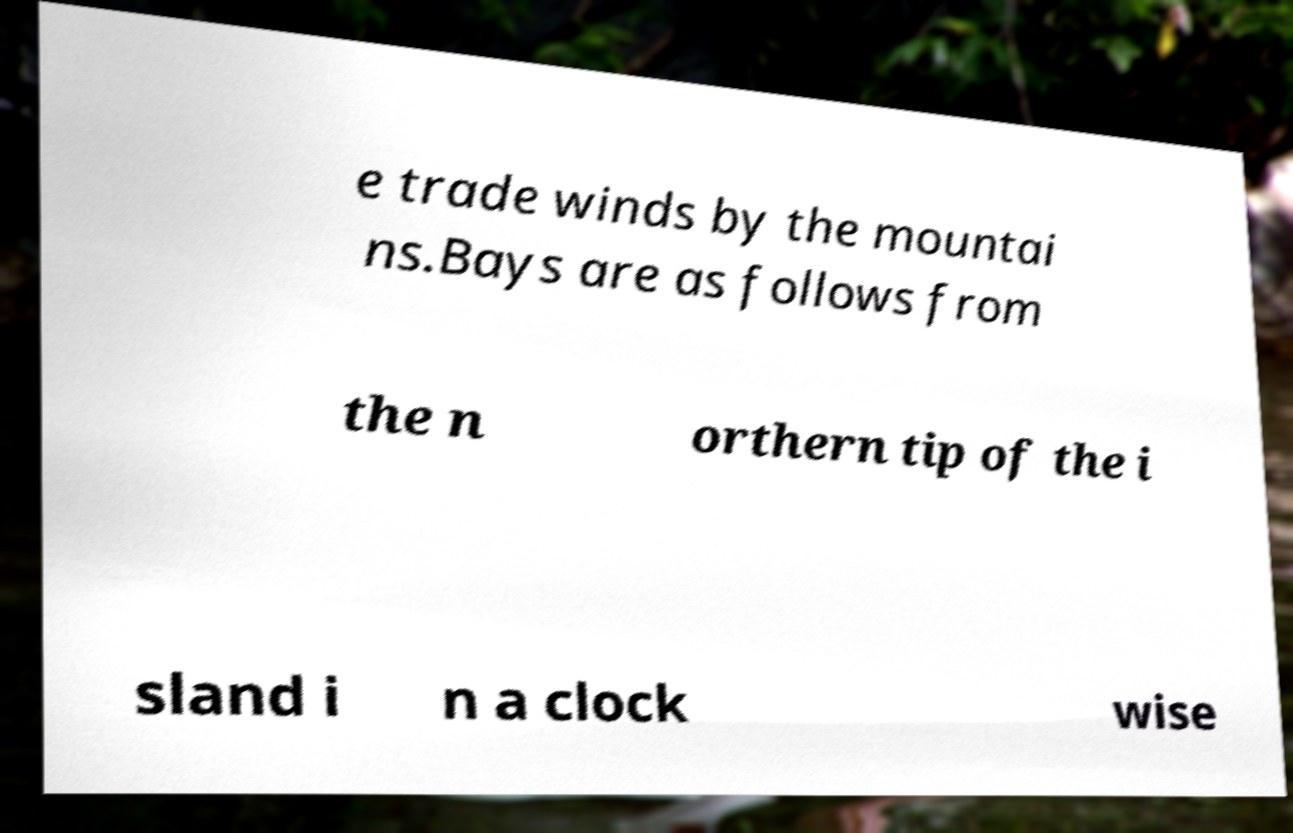Please identify and transcribe the text found in this image. e trade winds by the mountai ns.Bays are as follows from the n orthern tip of the i sland i n a clock wise 